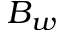<formula> <loc_0><loc_0><loc_500><loc_500>B _ { w }</formula> 